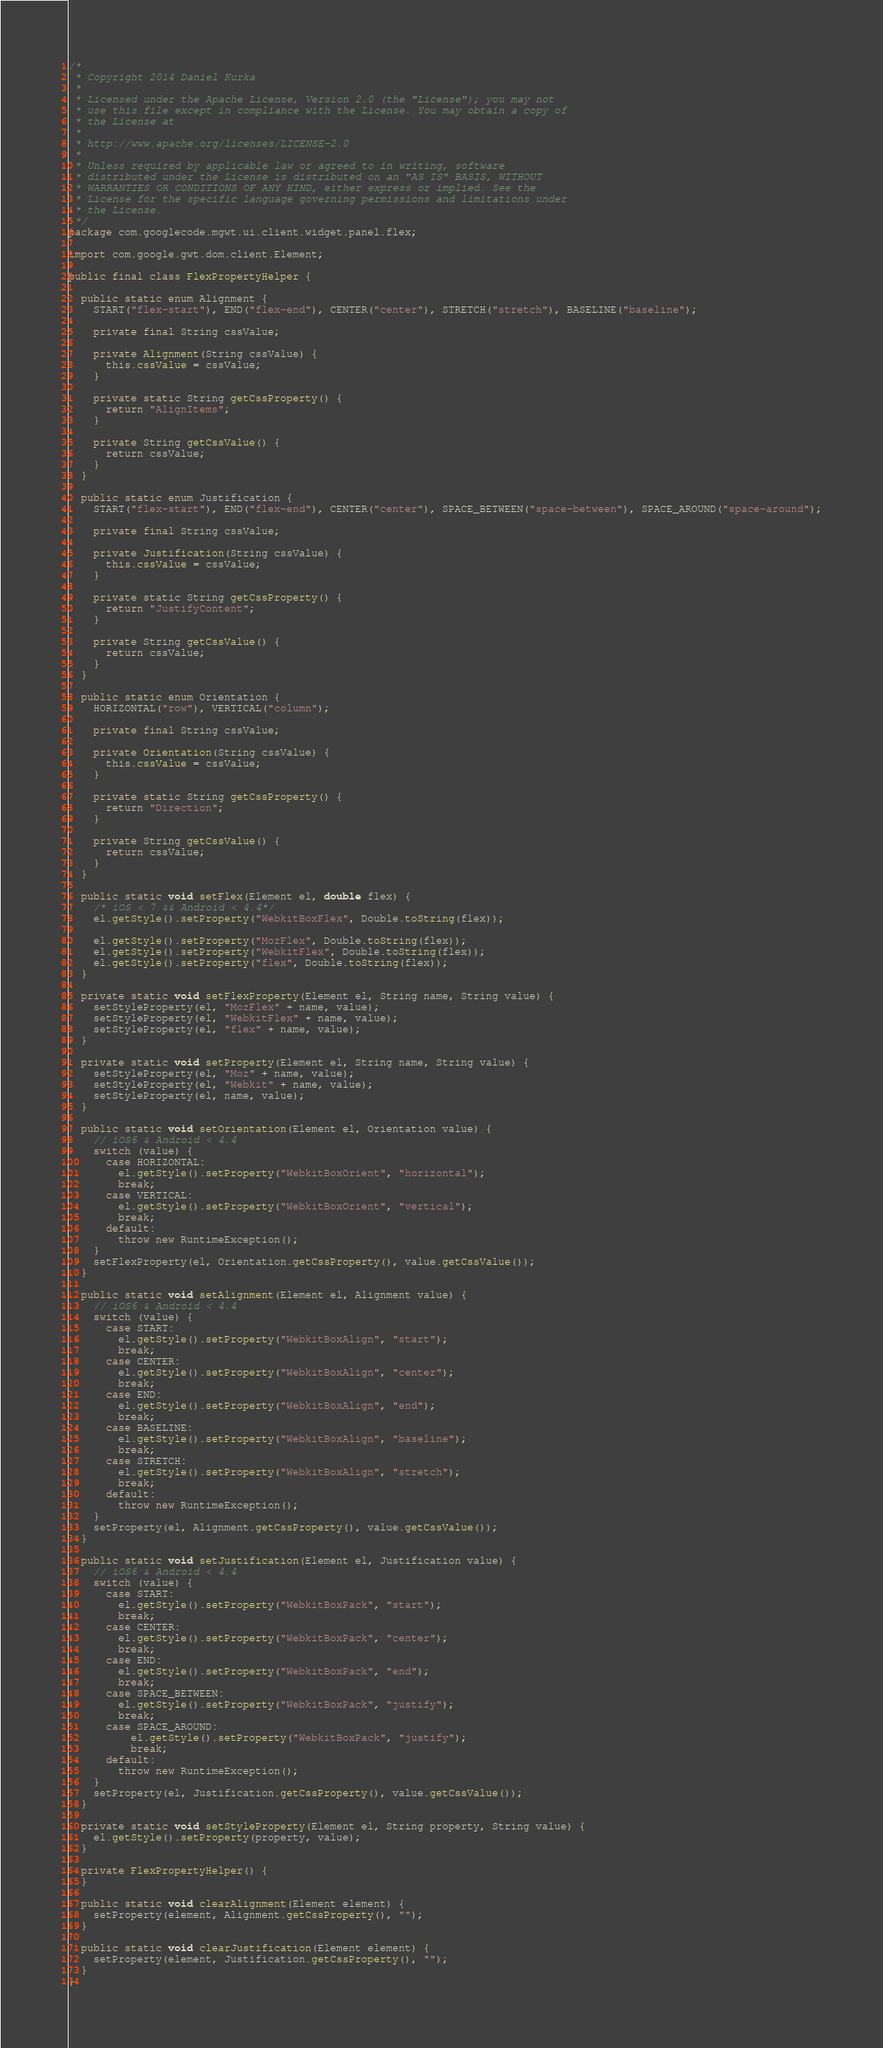<code> <loc_0><loc_0><loc_500><loc_500><_Java_>/*
 * Copyright 2014 Daniel Kurka
 *
 * Licensed under the Apache License, Version 2.0 (the "License"); you may not
 * use this file except in compliance with the License. You may obtain a copy of
 * the License at
 *
 * http://www.apache.org/licenses/LICENSE-2.0
 *
 * Unless required by applicable law or agreed to in writing, software
 * distributed under the License is distributed on an "AS IS" BASIS, WITHOUT
 * WARRANTIES OR CONDITIONS OF ANY KIND, either express or implied. See the
 * License for the specific language governing permissions and limitations under
 * the License.
 */
package com.googlecode.mgwt.ui.client.widget.panel.flex;

import com.google.gwt.dom.client.Element;

public final class FlexPropertyHelper {

  public static enum Alignment {
    START("flex-start"), END("flex-end"), CENTER("center"), STRETCH("stretch"), BASELINE("baseline");

    private final String cssValue;

    private Alignment(String cssValue) {
      this.cssValue = cssValue;
    }

    private static String getCssProperty() {
      return "AlignItems";
    }

    private String getCssValue() {
      return cssValue;
    }
  }

  public static enum Justification {
    START("flex-start"), END("flex-end"), CENTER("center"), SPACE_BETWEEN("space-between"), SPACE_AROUND("space-around");

    private final String cssValue;

    private Justification(String cssValue) {
      this.cssValue = cssValue;
    }

    private static String getCssProperty() {
      return "JustifyContent";
    }

    private String getCssValue() {
      return cssValue;
    }
  }

  public static enum Orientation {
    HORIZONTAL("row"), VERTICAL("column");

    private final String cssValue;

    private Orientation(String cssValue) {
      this.cssValue = cssValue;
    }

    private static String getCssProperty() {
      return "Direction";
    }

    private String getCssValue() {
      return cssValue;
    }
  }

  public static void setFlex(Element el, double flex) {
    /* iOS < 7 && Android < 4.4*/
    el.getStyle().setProperty("WebkitBoxFlex", Double.toString(flex));

    el.getStyle().setProperty("MozFlex", Double.toString(flex));
    el.getStyle().setProperty("WebkitFlex", Double.toString(flex));
    el.getStyle().setProperty("flex", Double.toString(flex));
  }

  private static void setFlexProperty(Element el, String name, String value) {
    setStyleProperty(el, "MozFlex" + name, value);
    setStyleProperty(el, "WebkitFlex" + name, value);
    setStyleProperty(el, "flex" + name, value);
  }

  private static void setProperty(Element el, String name, String value) {
    setStyleProperty(el, "Moz" + name, value);
    setStyleProperty(el, "Webkit" + name, value);
    setStyleProperty(el, name, value);
  }

  public static void setOrientation(Element el, Orientation value) {
    // iOS6 & Android < 4.4
    switch (value) {
      case HORIZONTAL:
        el.getStyle().setProperty("WebkitBoxOrient", "horizontal");
        break;
      case VERTICAL:
        el.getStyle().setProperty("WebkitBoxOrient", "vertical");
        break;
      default:
        throw new RuntimeException();
    }
    setFlexProperty(el, Orientation.getCssProperty(), value.getCssValue());
  }

  public static void setAlignment(Element el, Alignment value) {
    // iOS6 & Android < 4.4
    switch (value) {
      case START:
        el.getStyle().setProperty("WebkitBoxAlign", "start");
        break;
      case CENTER:
        el.getStyle().setProperty("WebkitBoxAlign", "center");
        break;
      case END:
        el.getStyle().setProperty("WebkitBoxAlign", "end");
        break;
      case BASELINE:
        el.getStyle().setProperty("WebkitBoxAlign", "baseline");
        break;
      case STRETCH:
        el.getStyle().setProperty("WebkitBoxAlign", "stretch");
        break;
      default:
        throw new RuntimeException();
    }
    setProperty(el, Alignment.getCssProperty(), value.getCssValue());
  }

  public static void setJustification(Element el, Justification value) {
    // iOS6 & Android < 4.4
    switch (value) {
      case START:
        el.getStyle().setProperty("WebkitBoxPack", "start");
        break;
      case CENTER:
        el.getStyle().setProperty("WebkitBoxPack", "center");
        break;
      case END:
        el.getStyle().setProperty("WebkitBoxPack", "end");
        break;
      case SPACE_BETWEEN:
        el.getStyle().setProperty("WebkitBoxPack", "justify");
        break;
      case SPACE_AROUND:
          el.getStyle().setProperty("WebkitBoxPack", "justify");
          break;
      default:
        throw new RuntimeException();
    }
    setProperty(el, Justification.getCssProperty(), value.getCssValue());
  }

  private static void setStyleProperty(Element el, String property, String value) {
    el.getStyle().setProperty(property, value);
  }

  private FlexPropertyHelper() {
  }

  public static void clearAlignment(Element element) {
    setProperty(element, Alignment.getCssProperty(), "");
  }

  public static void clearJustification(Element element) {
    setProperty(element, Justification.getCssProperty(), "");
  }
}
</code> 